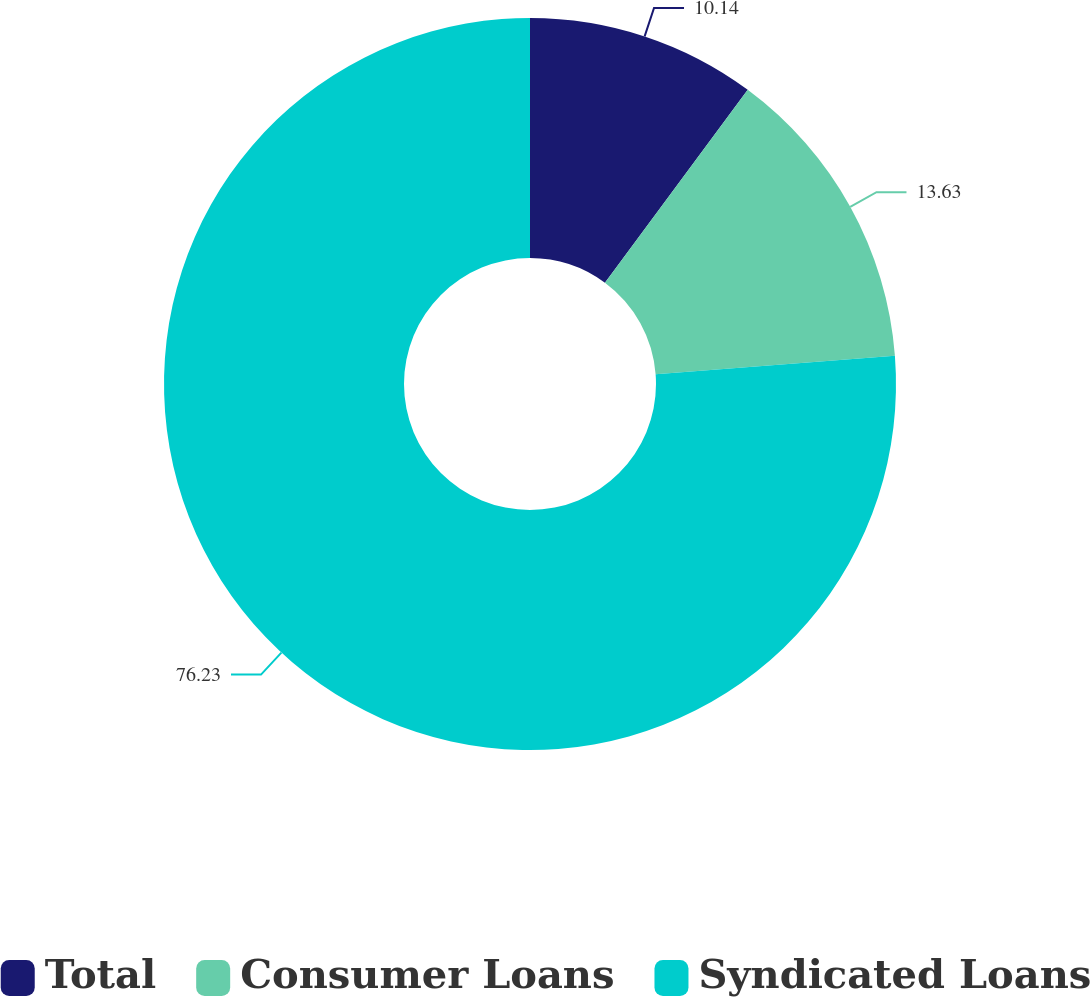Convert chart. <chart><loc_0><loc_0><loc_500><loc_500><pie_chart><fcel>Total<fcel>Consumer Loans<fcel>Syndicated Loans<nl><fcel>10.14%<fcel>13.63%<fcel>76.23%<nl></chart> 